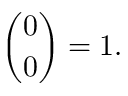<formula> <loc_0><loc_0><loc_500><loc_500>{ \binom { 0 } { 0 } } = 1 .</formula> 